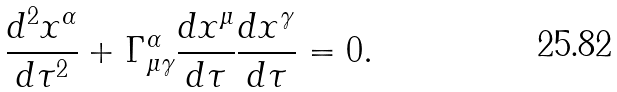<formula> <loc_0><loc_0><loc_500><loc_500>\frac { d ^ { 2 } x ^ { \alpha } } { d \tau ^ { 2 } } + \Gamma _ { \mu \gamma } ^ { \alpha } \frac { d x ^ { \mu } } { d \tau } \frac { d x ^ { \gamma } } { d \tau } = 0 .</formula> 